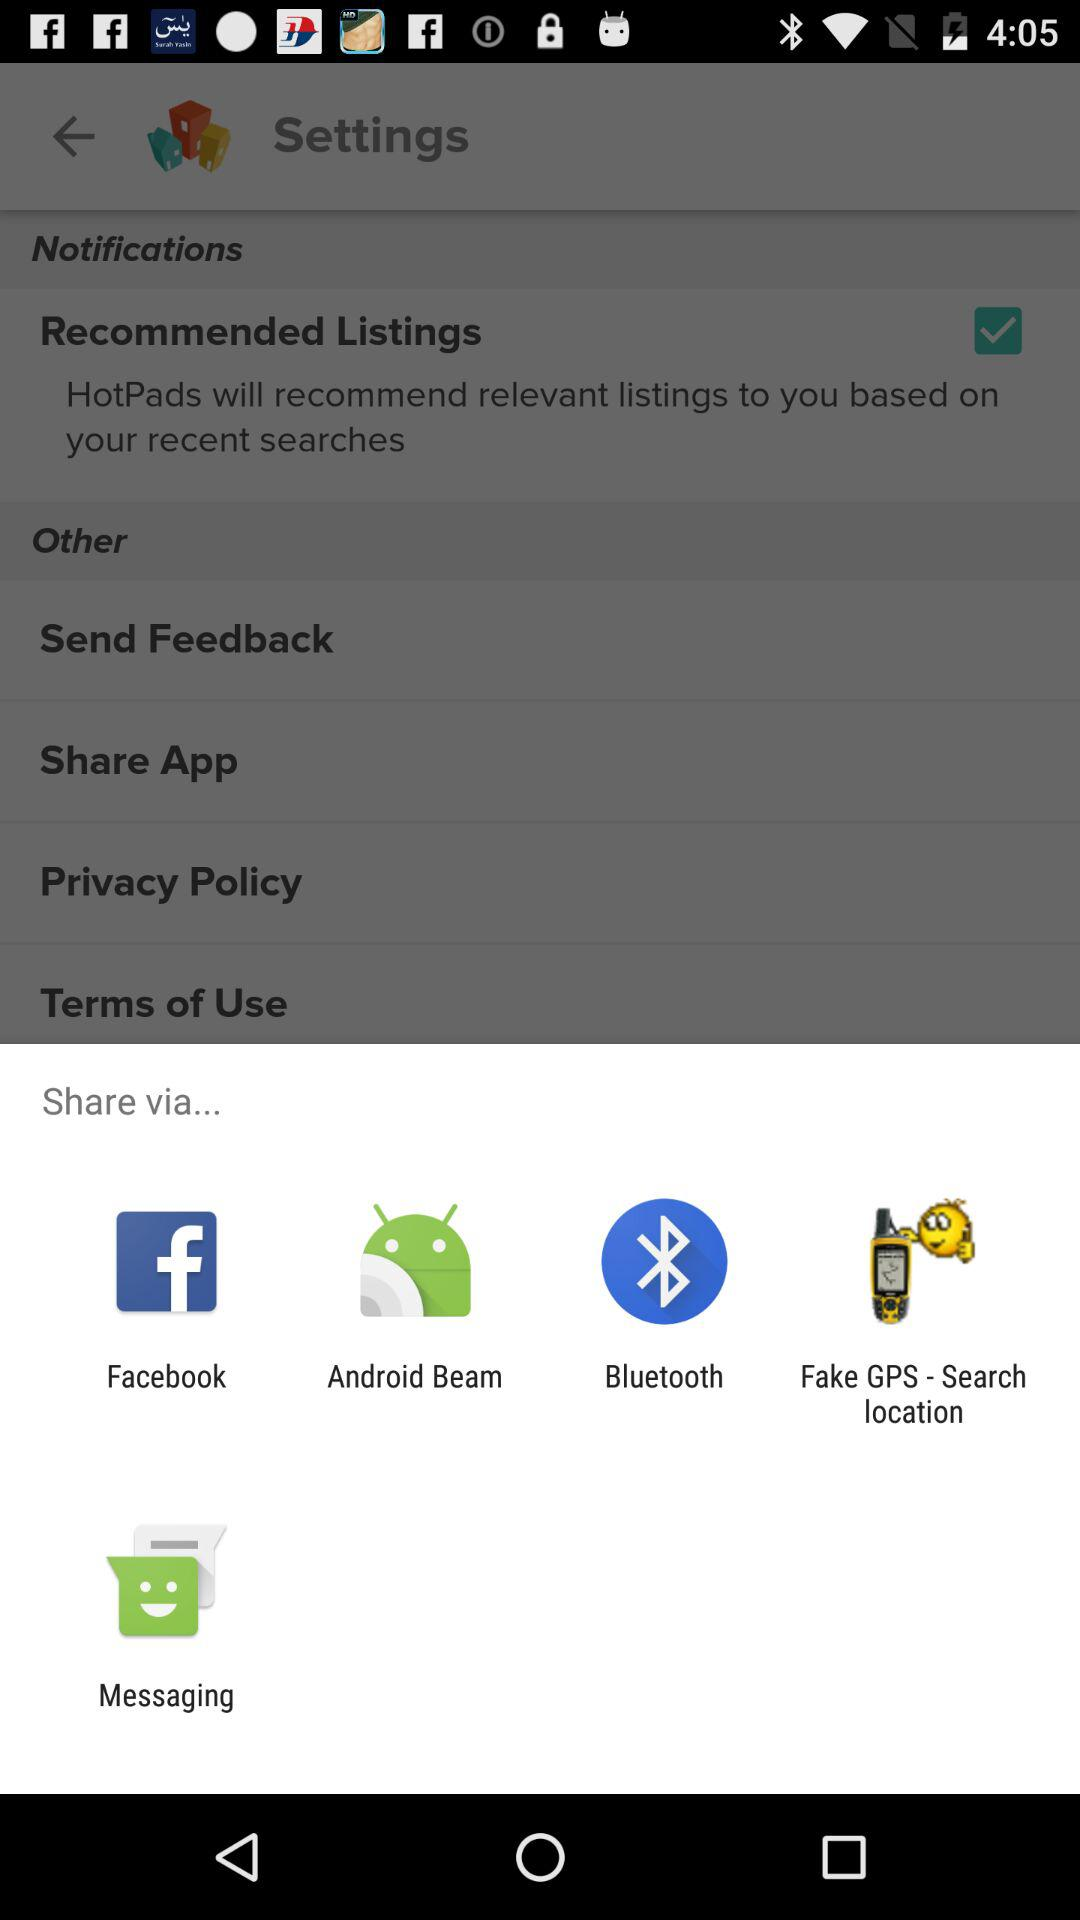Where does feedback get sent to?
When the provided information is insufficient, respond with <no answer>. <no answer> 